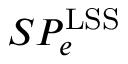Convert formula to latex. <formula><loc_0><loc_0><loc_500><loc_500>S P _ { e } ^ { L S S }</formula> 